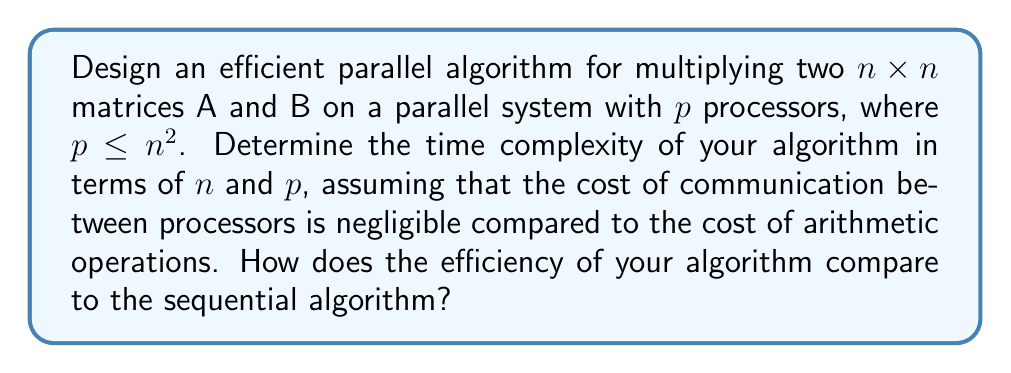Teach me how to tackle this problem. To design an efficient parallel algorithm for matrix multiplication, we can use the following approach:

1. Divide the result matrix C into $p$ equal parts, assigning each part to one processor.

2. Each processor will be responsible for computing $\frac{n^2}{p}$ elements of the result matrix C.

3. Broadcast matrix A and B to all processors.

4. Each processor performs the necessary multiplications and additions for its assigned elements of C.

5. Combine the results from all processors to form the final result matrix C.

Let's analyze the time complexity:

1. Broadcasting matrices A and B to all processors: $O(n^2)$

2. Computation on each processor:
   Each processor computes $\frac{n^2}{p}$ elements of C.
   For each element, it performs $n$ multiplications and $n-1$ additions.
   Time for each processor: $O(\frac{n^3}{p})$

3. Combining results: $O(n^2)$

Total time complexity: $T(n,p) = O(n^2 + \frac{n^3}{p} + n^2) = O(\frac{n^3}{p} + n^2)$

Efficiency analysis:
The sequential algorithm for matrix multiplication has a time complexity of $O(n^3)$.

Speedup: $S(n,p) = \frac{\text{Sequential time}}{\text{Parallel time}} = \frac{O(n^3)}{O(\frac{n^3}{p} + n^2)} \approx O(p)$ for large $n$

Efficiency: $E(n,p) = \frac{\text{Speedup}}{\text{Number of processors}} = \frac{O(p)}{p} \approx O(1)$

This indicates that the parallel algorithm achieves linear speedup and constant efficiency for large $n$, making it an efficient parallelization of the matrix multiplication problem.
Answer: The time complexity of the parallel matrix multiplication algorithm is $O(\frac{n^3}{p} + n^2)$, where $n$ is the size of the matrices and $p$ is the number of processors. The algorithm achieves linear speedup and constant efficiency for large $n$, making it significantly more efficient than the sequential algorithm for sufficiently large matrices. 